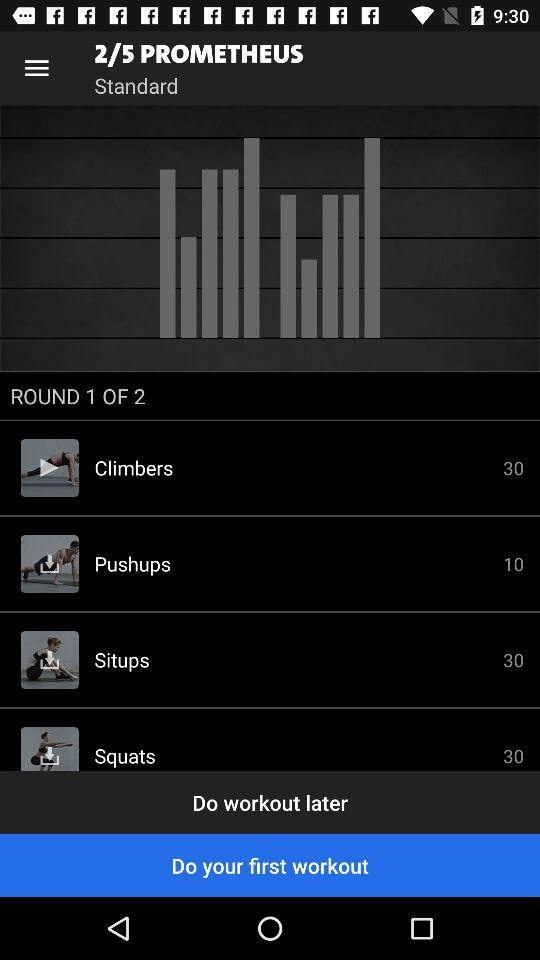How many pushups have to be done? You have to do 10 pushups. 